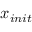<formula> <loc_0><loc_0><loc_500><loc_500>x _ { i n i t }</formula> 